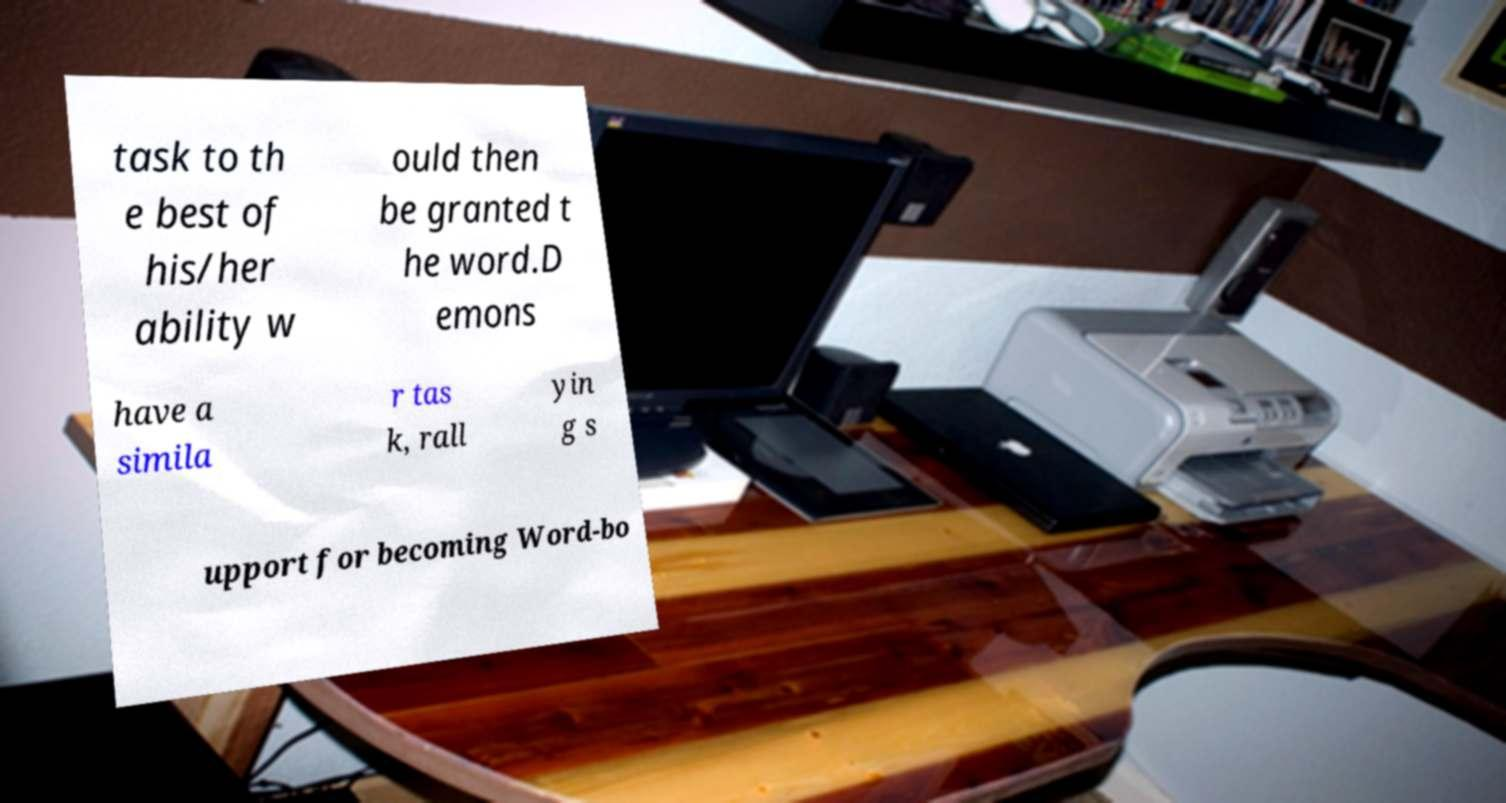Could you extract and type out the text from this image? task to th e best of his/her ability w ould then be granted t he word.D emons have a simila r tas k, rall yin g s upport for becoming Word-bo 